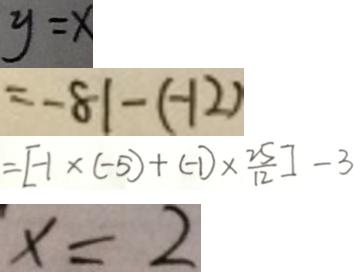<formula> <loc_0><loc_0><loc_500><loc_500>y = x 
 = - 8 1 - ( - 1 2 ) 
 = [ - 1 \times ( - 5 ) + ( - 1 ) \times \frac { 2 5 } { 1 2 } ] - 3 
 x = 2</formula> 